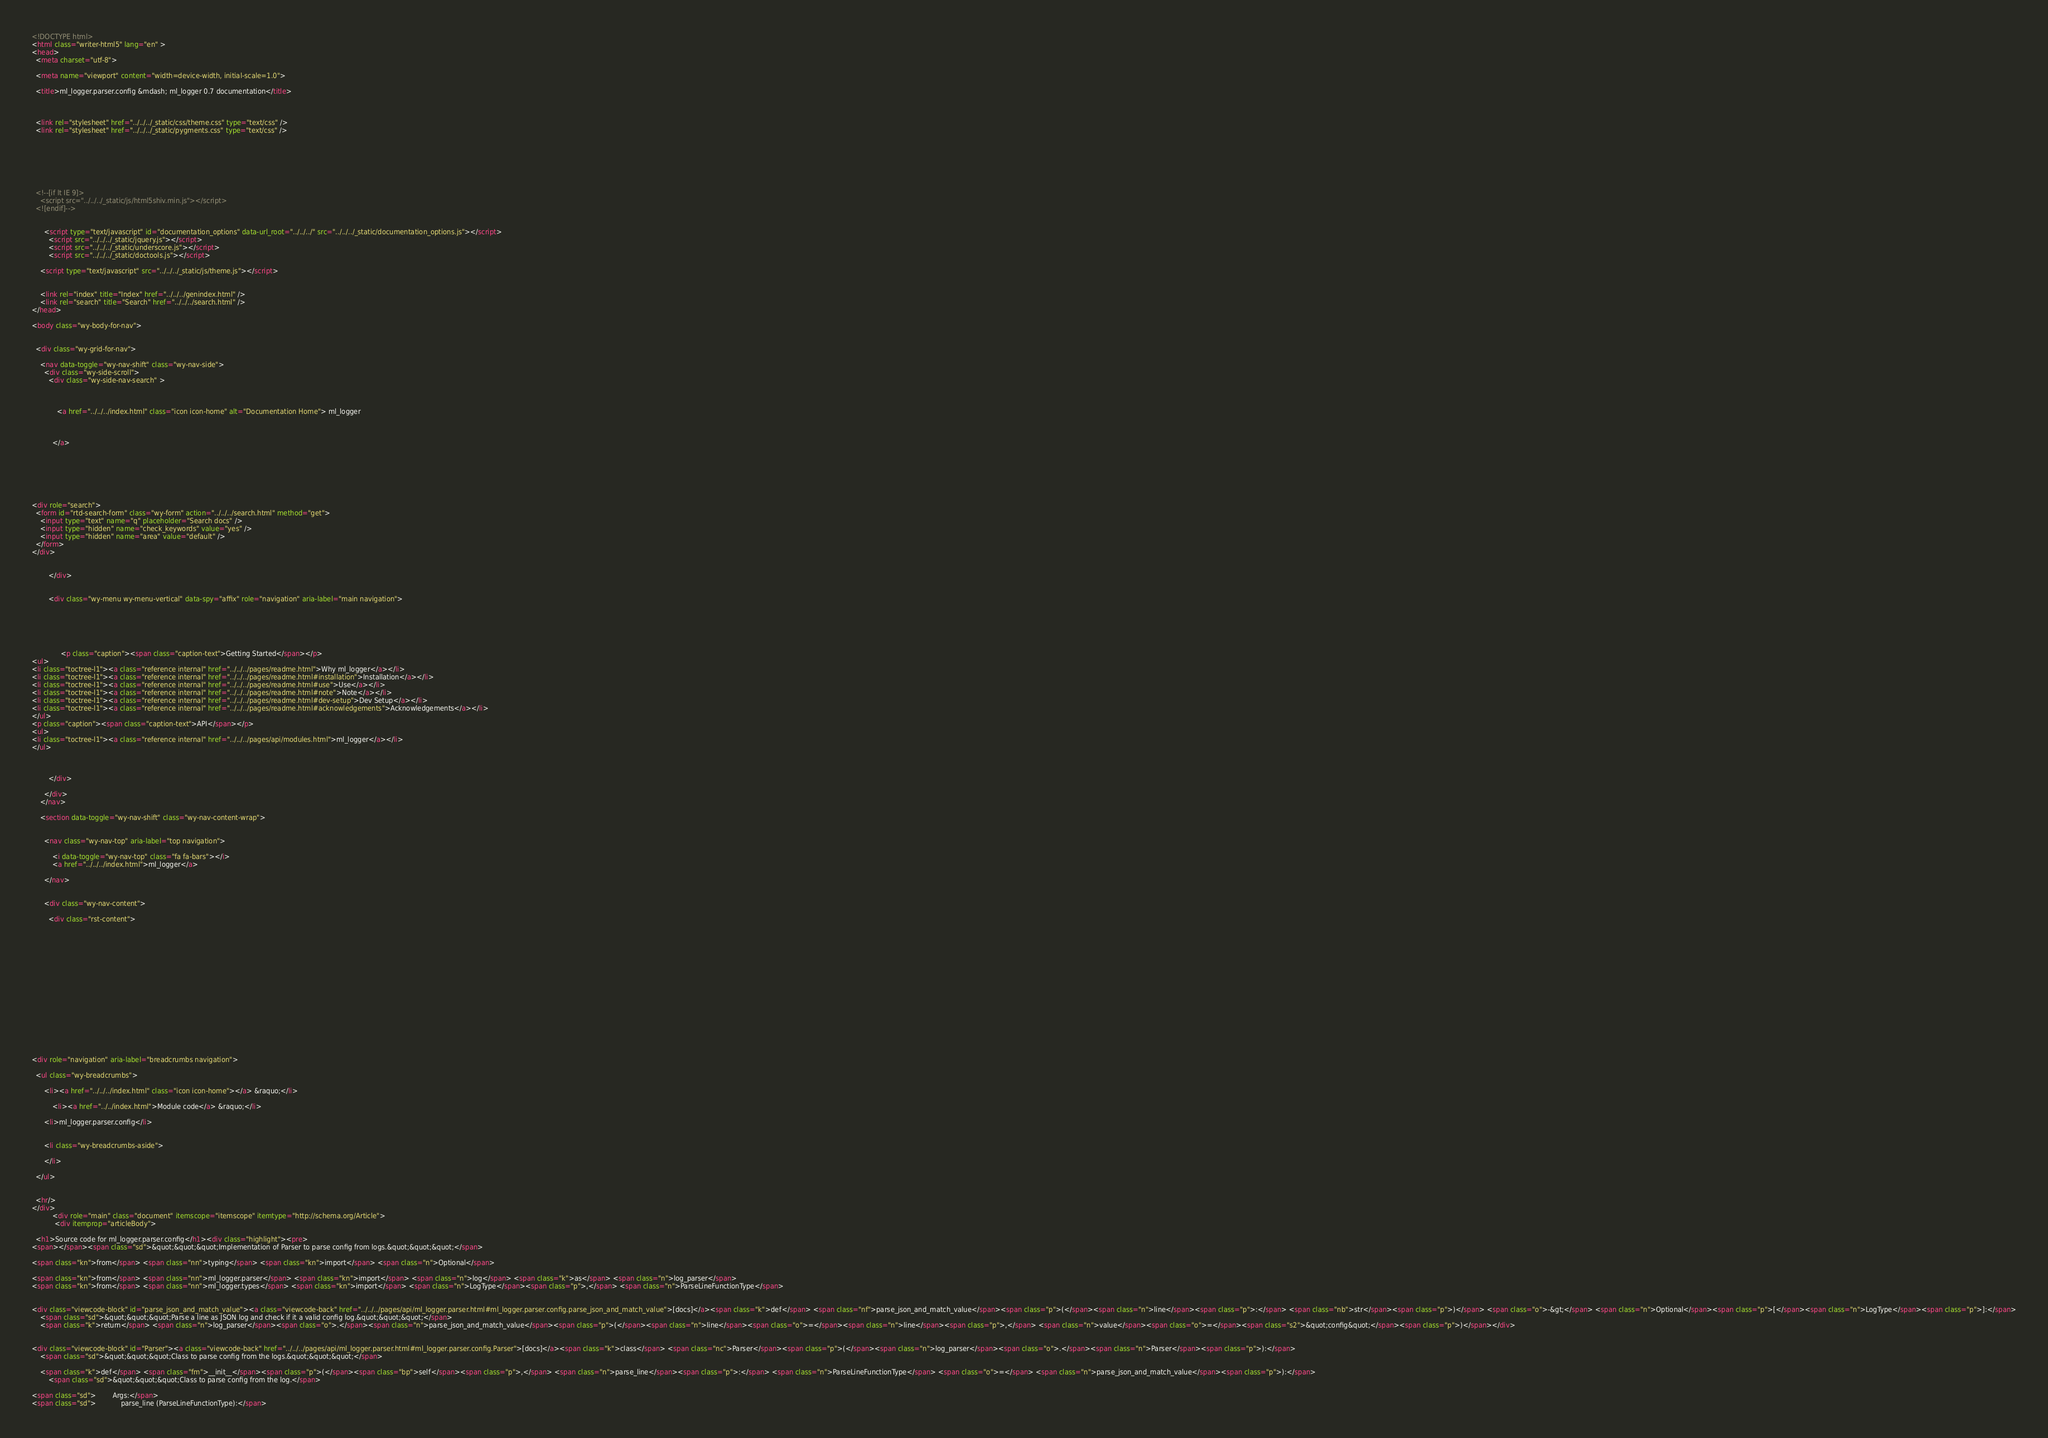<code> <loc_0><loc_0><loc_500><loc_500><_HTML_>

<!DOCTYPE html>
<html class="writer-html5" lang="en" >
<head>
  <meta charset="utf-8">
  
  <meta name="viewport" content="width=device-width, initial-scale=1.0">
  
  <title>ml_logger.parser.config &mdash; ml_logger 0.7 documentation</title>
  

  
  <link rel="stylesheet" href="../../../_static/css/theme.css" type="text/css" />
  <link rel="stylesheet" href="../../../_static/pygments.css" type="text/css" />

  
  
  
  

  
  <!--[if lt IE 9]>
    <script src="../../../_static/js/html5shiv.min.js"></script>
  <![endif]-->
  
    
      <script type="text/javascript" id="documentation_options" data-url_root="../../../" src="../../../_static/documentation_options.js"></script>
        <script src="../../../_static/jquery.js"></script>
        <script src="../../../_static/underscore.js"></script>
        <script src="../../../_static/doctools.js"></script>
    
    <script type="text/javascript" src="../../../_static/js/theme.js"></script>

    
    <link rel="index" title="Index" href="../../../genindex.html" />
    <link rel="search" title="Search" href="../../../search.html" /> 
</head>

<body class="wy-body-for-nav">

   
  <div class="wy-grid-for-nav">
    
    <nav data-toggle="wy-nav-shift" class="wy-nav-side">
      <div class="wy-side-scroll">
        <div class="wy-side-nav-search" >
          

          
            <a href="../../../index.html" class="icon icon-home" alt="Documentation Home"> ml_logger
          

          
          </a>

          
            
            
          

          
<div role="search">
  <form id="rtd-search-form" class="wy-form" action="../../../search.html" method="get">
    <input type="text" name="q" placeholder="Search docs" />
    <input type="hidden" name="check_keywords" value="yes" />
    <input type="hidden" name="area" value="default" />
  </form>
</div>

          
        </div>

        
        <div class="wy-menu wy-menu-vertical" data-spy="affix" role="navigation" aria-label="main navigation">
          
            
            
              
            
            
              <p class="caption"><span class="caption-text">Getting Started</span></p>
<ul>
<li class="toctree-l1"><a class="reference internal" href="../../../pages/readme.html">Why ml_logger</a></li>
<li class="toctree-l1"><a class="reference internal" href="../../../pages/readme.html#installation">Installation</a></li>
<li class="toctree-l1"><a class="reference internal" href="../../../pages/readme.html#use">Use</a></li>
<li class="toctree-l1"><a class="reference internal" href="../../../pages/readme.html#note">Note</a></li>
<li class="toctree-l1"><a class="reference internal" href="../../../pages/readme.html#dev-setup">Dev Setup</a></li>
<li class="toctree-l1"><a class="reference internal" href="../../../pages/readme.html#acknowledgements">Acknowledgements</a></li>
</ul>
<p class="caption"><span class="caption-text">API</span></p>
<ul>
<li class="toctree-l1"><a class="reference internal" href="../../../pages/api/modules.html">ml_logger</a></li>
</ul>

            
          
        </div>
        
      </div>
    </nav>

    <section data-toggle="wy-nav-shift" class="wy-nav-content-wrap">

      
      <nav class="wy-nav-top" aria-label="top navigation">
        
          <i data-toggle="wy-nav-top" class="fa fa-bars"></i>
          <a href="../../../index.html">ml_logger</a>
        
      </nav>


      <div class="wy-nav-content">
        
        <div class="rst-content">
        
          















<div role="navigation" aria-label="breadcrumbs navigation">

  <ul class="wy-breadcrumbs">
    
      <li><a href="../../../index.html" class="icon icon-home"></a> &raquo;</li>
        
          <li><a href="../../index.html">Module code</a> &raquo;</li>
        
      <li>ml_logger.parser.config</li>
    
    
      <li class="wy-breadcrumbs-aside">
        
      </li>
    
  </ul>

  
  <hr/>
</div>
          <div role="main" class="document" itemscope="itemscope" itemtype="http://schema.org/Article">
           <div itemprop="articleBody">
            
  <h1>Source code for ml_logger.parser.config</h1><div class="highlight"><pre>
<span></span><span class="sd">&quot;&quot;&quot;Implementation of Parser to parse config from logs.&quot;&quot;&quot;</span>

<span class="kn">from</span> <span class="nn">typing</span> <span class="kn">import</span> <span class="n">Optional</span>

<span class="kn">from</span> <span class="nn">ml_logger.parser</span> <span class="kn">import</span> <span class="n">log</span> <span class="k">as</span> <span class="n">log_parser</span>
<span class="kn">from</span> <span class="nn">ml_logger.types</span> <span class="kn">import</span> <span class="n">LogType</span><span class="p">,</span> <span class="n">ParseLineFunctionType</span>


<div class="viewcode-block" id="parse_json_and_match_value"><a class="viewcode-back" href="../../../pages/api/ml_logger.parser.html#ml_logger.parser.config.parse_json_and_match_value">[docs]</a><span class="k">def</span> <span class="nf">parse_json_and_match_value</span><span class="p">(</span><span class="n">line</span><span class="p">:</span> <span class="nb">str</span><span class="p">)</span> <span class="o">-&gt;</span> <span class="n">Optional</span><span class="p">[</span><span class="n">LogType</span><span class="p">]:</span>
    <span class="sd">&quot;&quot;&quot;Parse a line as JSON log and check if it a valid config log.&quot;&quot;&quot;</span>
    <span class="k">return</span> <span class="n">log_parser</span><span class="o">.</span><span class="n">parse_json_and_match_value</span><span class="p">(</span><span class="n">line</span><span class="o">=</span><span class="n">line</span><span class="p">,</span> <span class="n">value</span><span class="o">=</span><span class="s2">&quot;config&quot;</span><span class="p">)</span></div>


<div class="viewcode-block" id="Parser"><a class="viewcode-back" href="../../../pages/api/ml_logger.parser.html#ml_logger.parser.config.Parser">[docs]</a><span class="k">class</span> <span class="nc">Parser</span><span class="p">(</span><span class="n">log_parser</span><span class="o">.</span><span class="n">Parser</span><span class="p">):</span>
    <span class="sd">&quot;&quot;&quot;Class to parse config from the logs.&quot;&quot;&quot;</span>

    <span class="k">def</span> <span class="fm">__init__</span><span class="p">(</span><span class="bp">self</span><span class="p">,</span> <span class="n">parse_line</span><span class="p">:</span> <span class="n">ParseLineFunctionType</span> <span class="o">=</span> <span class="n">parse_json_and_match_value</span><span class="p">):</span>
        <span class="sd">&quot;&quot;&quot;Class to parse config from the log.</span>

<span class="sd">        Args:</span>
<span class="sd">            parse_line (ParseLineFunctionType):</span></code> 